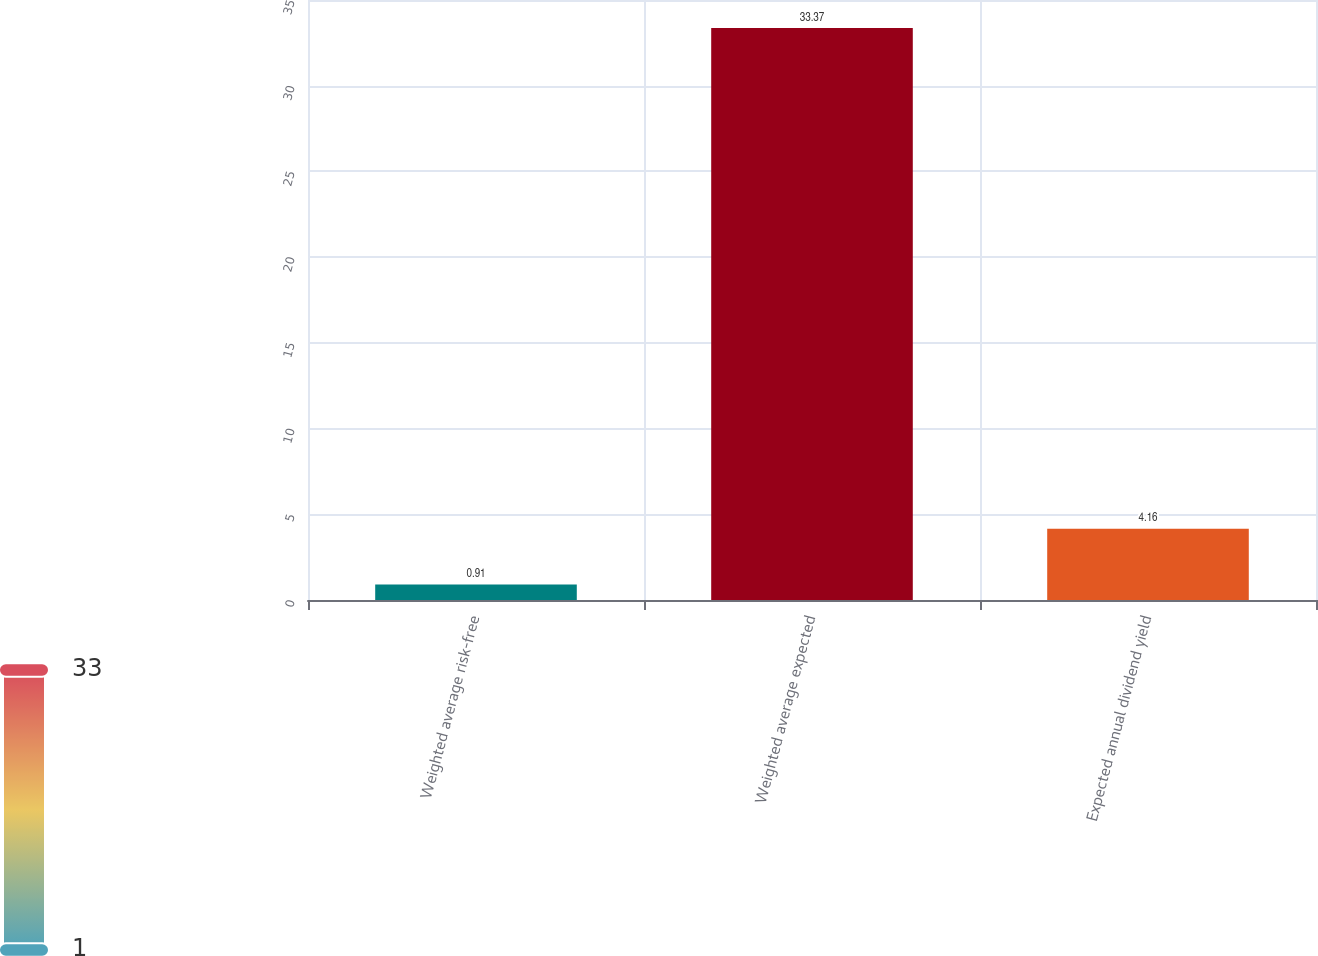<chart> <loc_0><loc_0><loc_500><loc_500><bar_chart><fcel>Weighted average risk-free<fcel>Weighted average expected<fcel>Expected annual dividend yield<nl><fcel>0.91<fcel>33.37<fcel>4.16<nl></chart> 